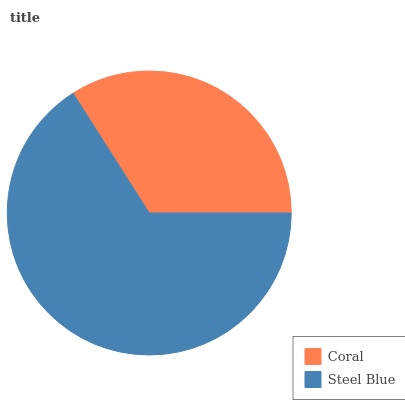Is Coral the minimum?
Answer yes or no. Yes. Is Steel Blue the maximum?
Answer yes or no. Yes. Is Steel Blue the minimum?
Answer yes or no. No. Is Steel Blue greater than Coral?
Answer yes or no. Yes. Is Coral less than Steel Blue?
Answer yes or no. Yes. Is Coral greater than Steel Blue?
Answer yes or no. No. Is Steel Blue less than Coral?
Answer yes or no. No. Is Steel Blue the high median?
Answer yes or no. Yes. Is Coral the low median?
Answer yes or no. Yes. Is Coral the high median?
Answer yes or no. No. Is Steel Blue the low median?
Answer yes or no. No. 